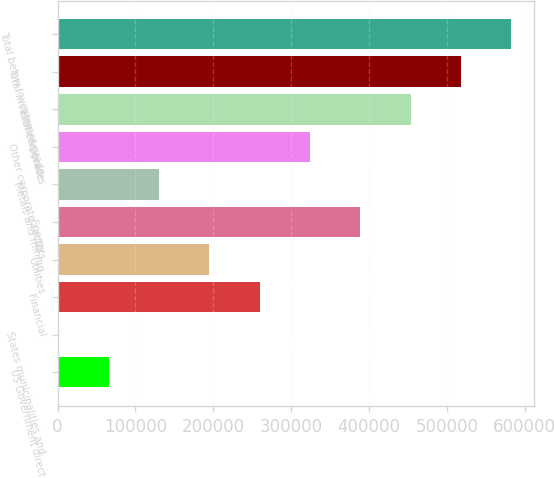Convert chart to OTSL. <chart><loc_0><loc_0><loc_500><loc_500><bar_chart><fcel>US Government direct<fcel>States municipalities and<fcel>Financial<fcel>Utilities<fcel>Energy<fcel>Metals and mining<fcel>Other corporate sectors<fcel>Total corporates<fcel>Total investment grade<fcel>Total below investment grade<nl><fcel>65367.5<fcel>683<fcel>259421<fcel>194736<fcel>388790<fcel>130052<fcel>324106<fcel>453474<fcel>518159<fcel>582844<nl></chart> 